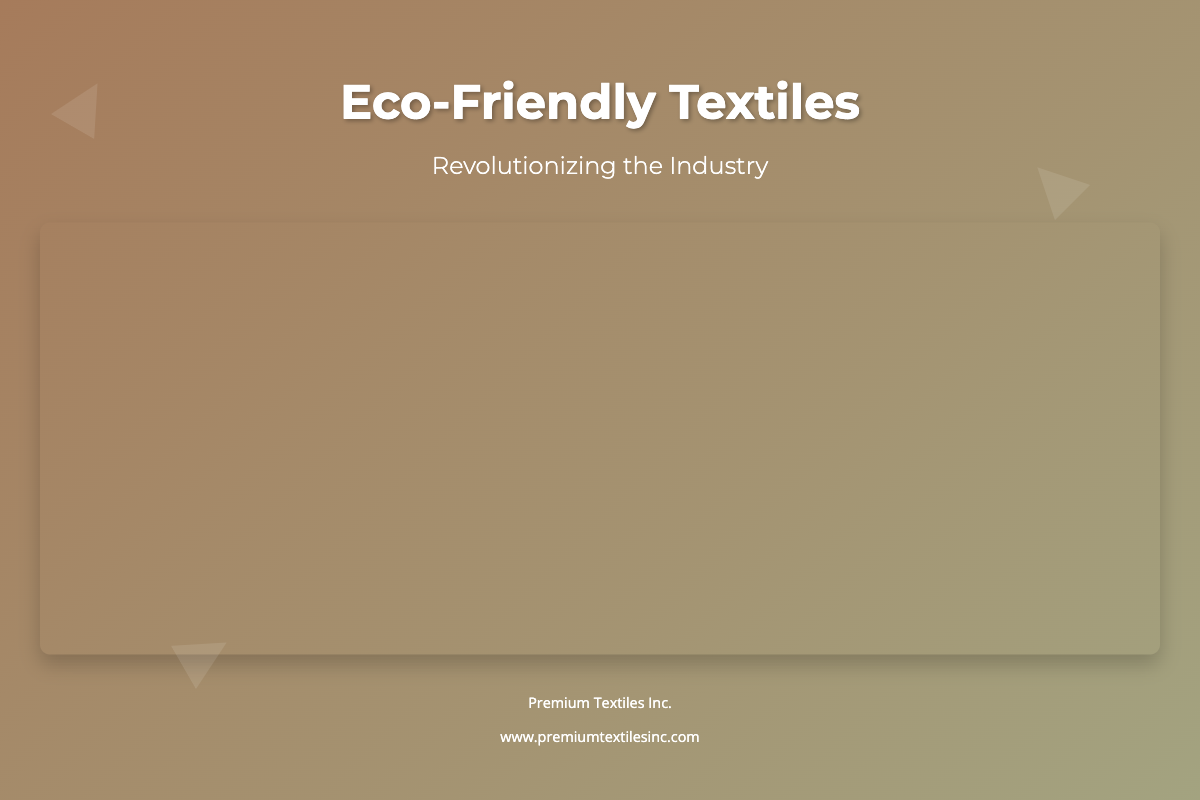What is the title of the book? The title is prominently displayed in the center of the cover.
Answer: Eco-Friendly Textiles What is the subtitle of the book? The subtitle is located directly beneath the title in a smaller font.
Answer: Revolutionizing the Industry What colors are used in the book cover's background? The background features a linear gradient of two colors seen at the top of the cover.
Answer: Earthy tones What company is mentioned on the footer of the cover? The footer contains the name of the company as a part of the book cover design.
Answer: Premium Textiles Inc What type of image is featured on the book cover? The image is described as being related to the theme of sustainable materials.
Answer: Sustainable textiles What is the main typography style used for the title? The title employs a specific font style that can be identified easily.
Answer: Montserrat How many decorative leaves are shown on the cover? The cover includes a specific number of stylistic elements resembling leaves.
Answer: Three What is the website link provided in the footer? The footer provides a URL that directs to the company's online presence.
Answer: www.premiumtextilesinc.com What kind of motifs are used in the book cover design? The design incorporates certain natural themes that relate to the overall eco-friendly message.
Answer: Natural motifs 